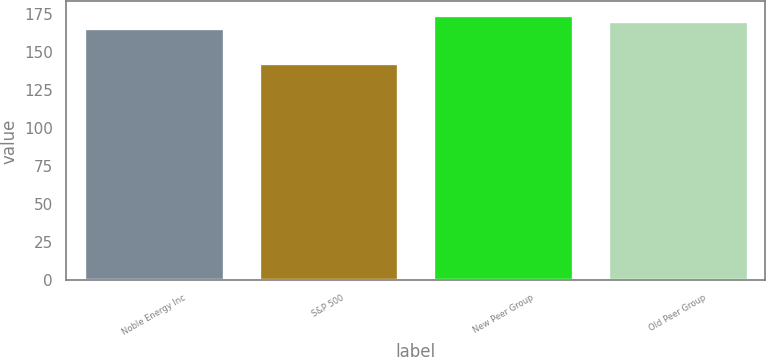Convert chart. <chart><loc_0><loc_0><loc_500><loc_500><bar_chart><fcel>Noble Energy Inc<fcel>S&P 500<fcel>New Peer Group<fcel>Old Peer Group<nl><fcel>165.66<fcel>142.69<fcel>174.5<fcel>170.44<nl></chart> 